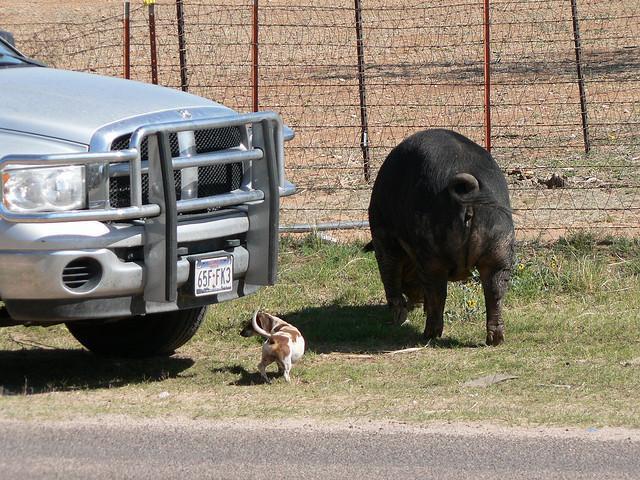How many animals?
Give a very brief answer. 2. How many animals are in the picture?
Give a very brief answer. 2. 